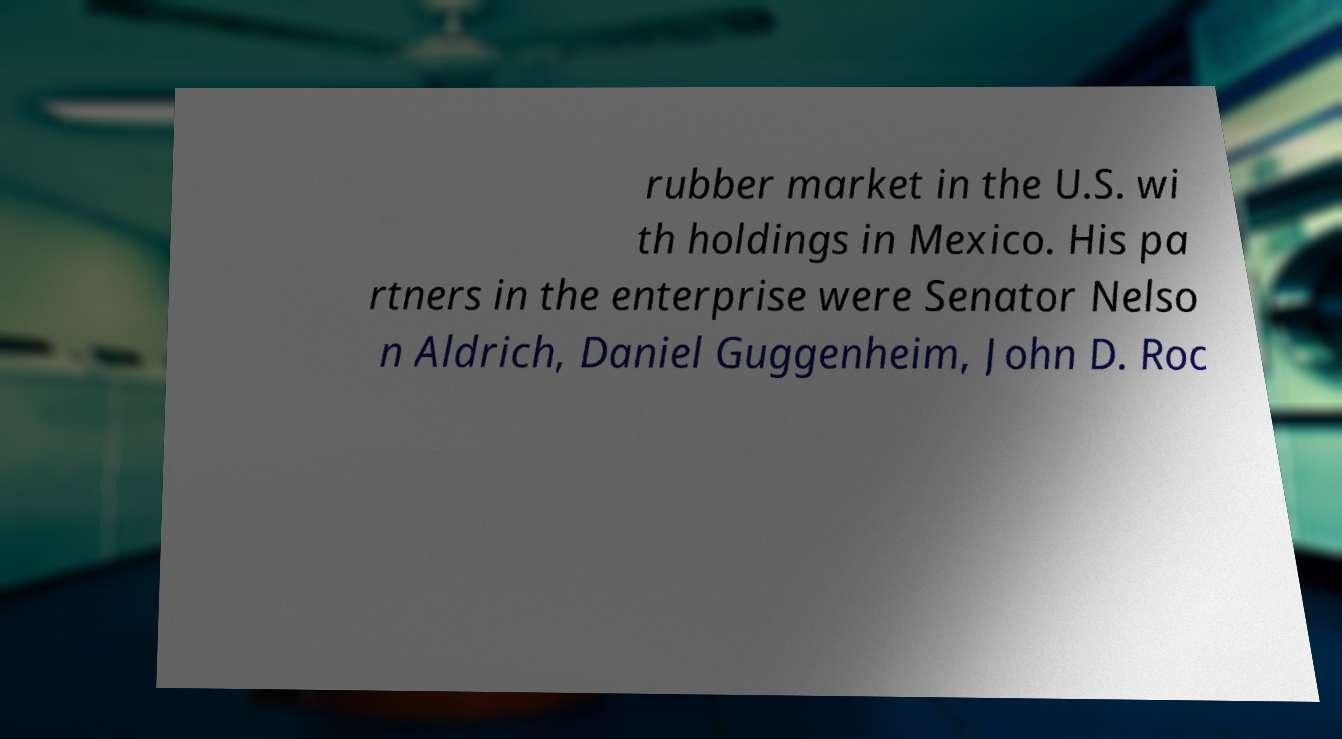Could you extract and type out the text from this image? rubber market in the U.S. wi th holdings in Mexico. His pa rtners in the enterprise were Senator Nelso n Aldrich, Daniel Guggenheim, John D. Roc 